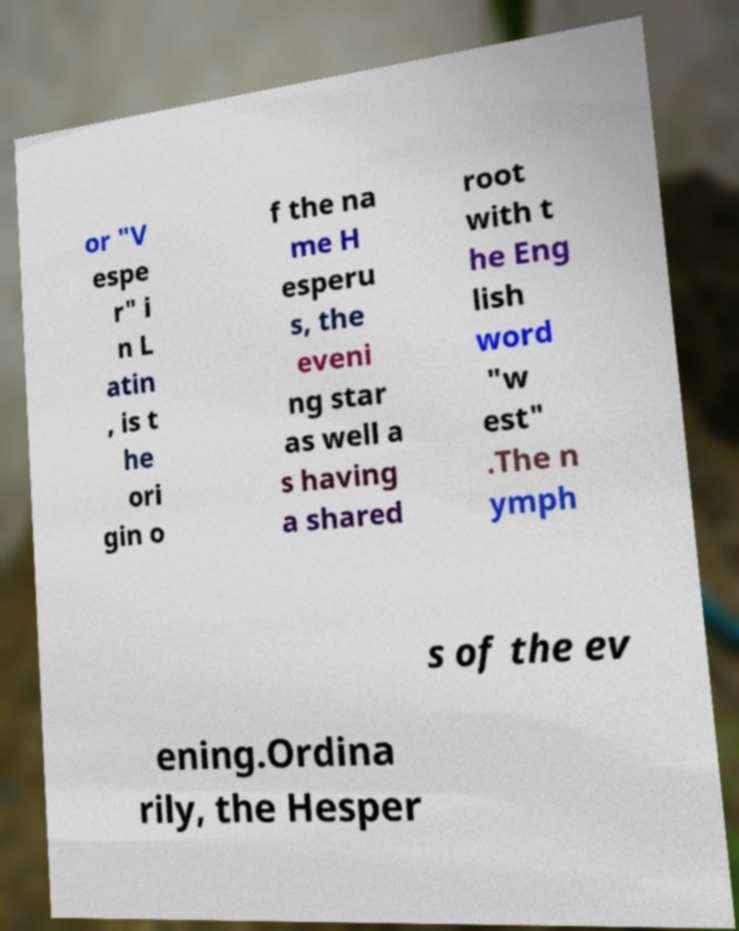For documentation purposes, I need the text within this image transcribed. Could you provide that? or "V espe r" i n L atin , is t he ori gin o f the na me H esperu s, the eveni ng star as well a s having a shared root with t he Eng lish word "w est" .The n ymph s of the ev ening.Ordina rily, the Hesper 